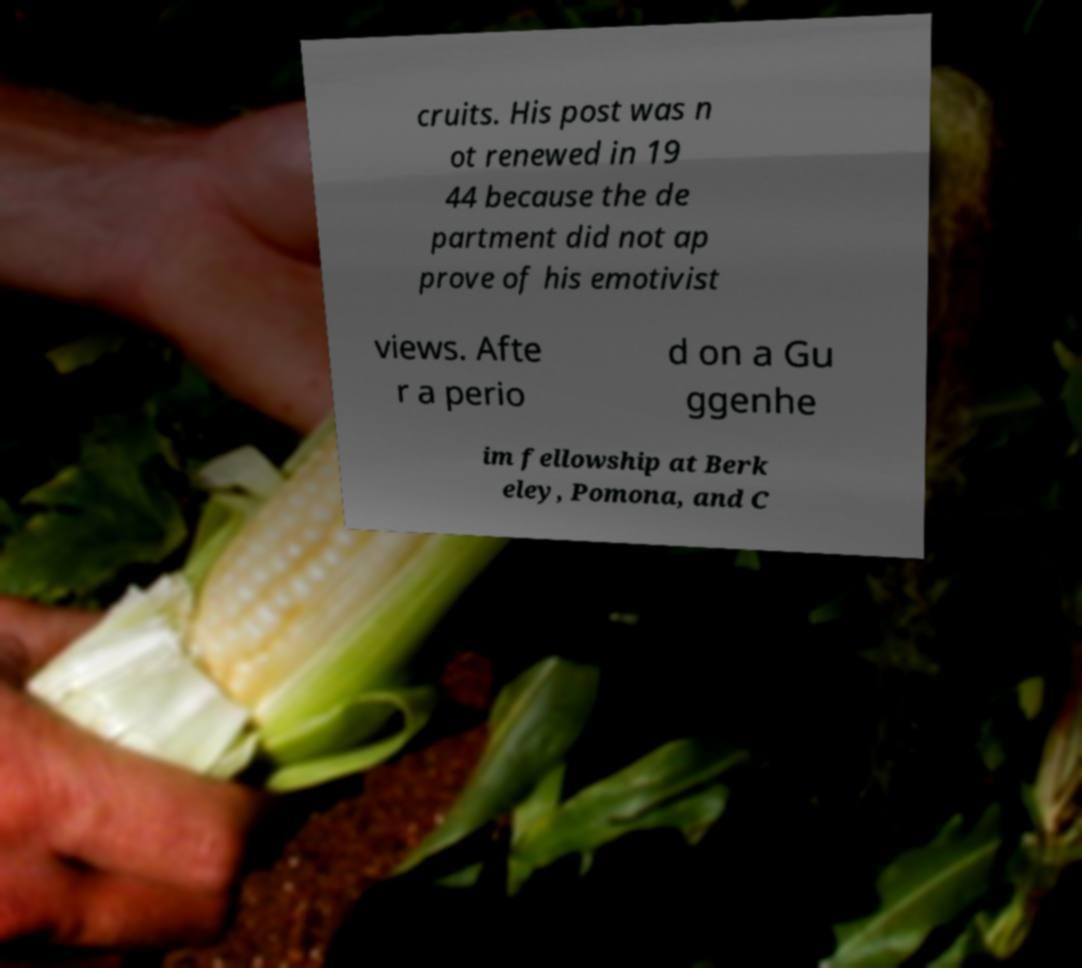What messages or text are displayed in this image? I need them in a readable, typed format. cruits. His post was n ot renewed in 19 44 because the de partment did not ap prove of his emotivist views. Afte r a perio d on a Gu ggenhe im fellowship at Berk eley, Pomona, and C 